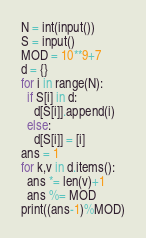Convert code to text. <code><loc_0><loc_0><loc_500><loc_500><_Python_>N = int(input())
S = input()
MOD = 10**9+7
d = {}
for i in range(N):
  if S[i] in d:
    d[S[i]].append(i)
  else:
    d[S[i]] = [i]
ans = 1
for k,v in d.items():
  ans *= len(v)+1
  ans %= MOD
print((ans-1)%MOD)
</code> 